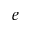<formula> <loc_0><loc_0><loc_500><loc_500>e</formula> 